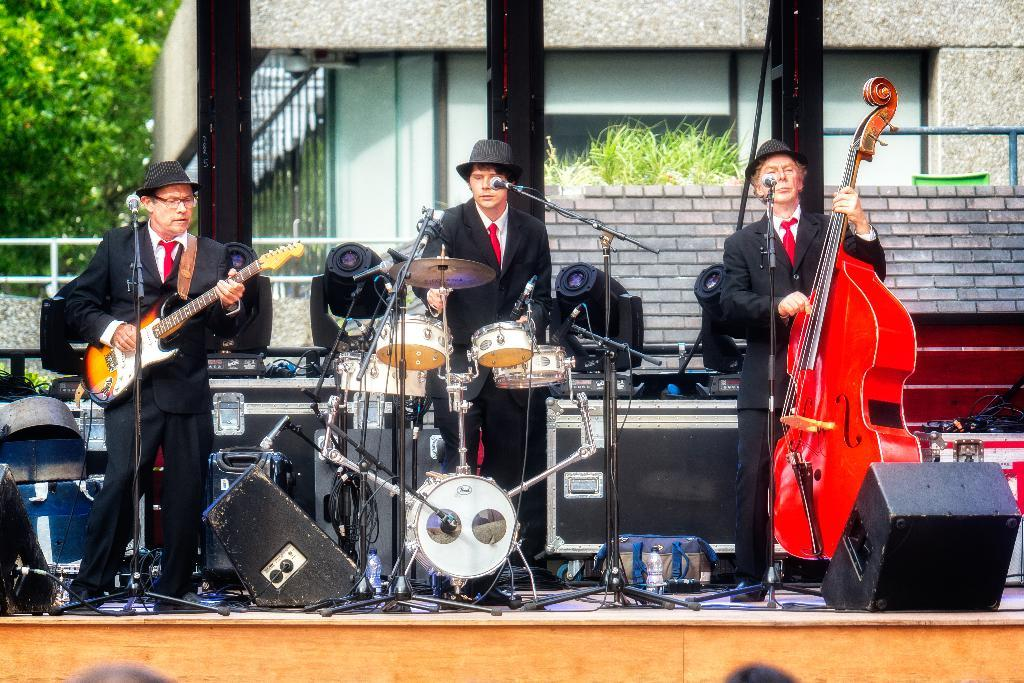How many people are on the stage in the image? There are three men on the stage in the image. What are the men doing on the stage? The men are performing. What are the men using to perform in the image? The men are playing musical instruments. What can be seen in the background of the image? There is a building, trees, and a pole in the background. Which man's knee is causing friction with the stage during the performance? There is no mention of any man's knee or friction with the stage in the image. 